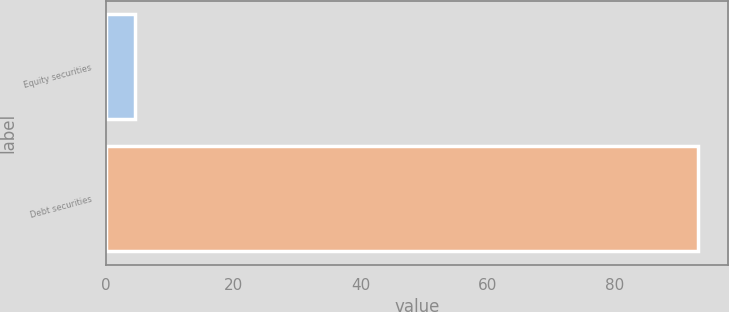<chart> <loc_0><loc_0><loc_500><loc_500><bar_chart><fcel>Equity securities<fcel>Debt securities<nl><fcel>4.61<fcel>93.1<nl></chart> 